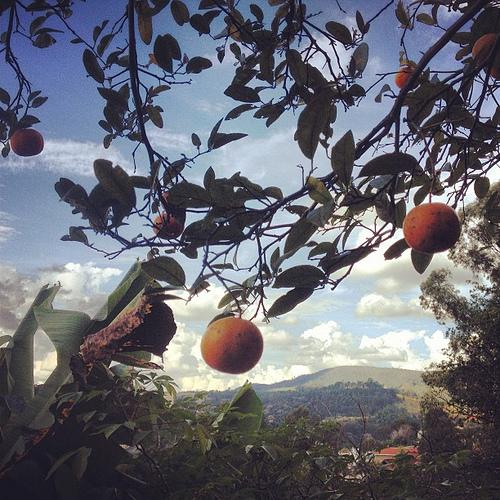Question: how many oranges are hanging on the branch in the front of the picture?
Choices:
A. Two.
B. Three.
C. Four.
D. Five.
Answer with the letter. Answer: A Question: what color is the fruit on the tree?
Choices:
A. Blue.
B. Green.
C. Orange.
D. Yellow.
Answer with the letter. Answer: C Question: what kinds of fruit is on the tree?
Choices:
A. Apples.
B. Peaches.
C. Oranges.
D. Cherries.
Answer with the letter. Answer: C Question: what kind of tree is in the picture?
Choices:
A. An apple tree.
B. A peach tree.
C. An orange tree.
D. A cherry tree.
Answer with the letter. Answer: C 